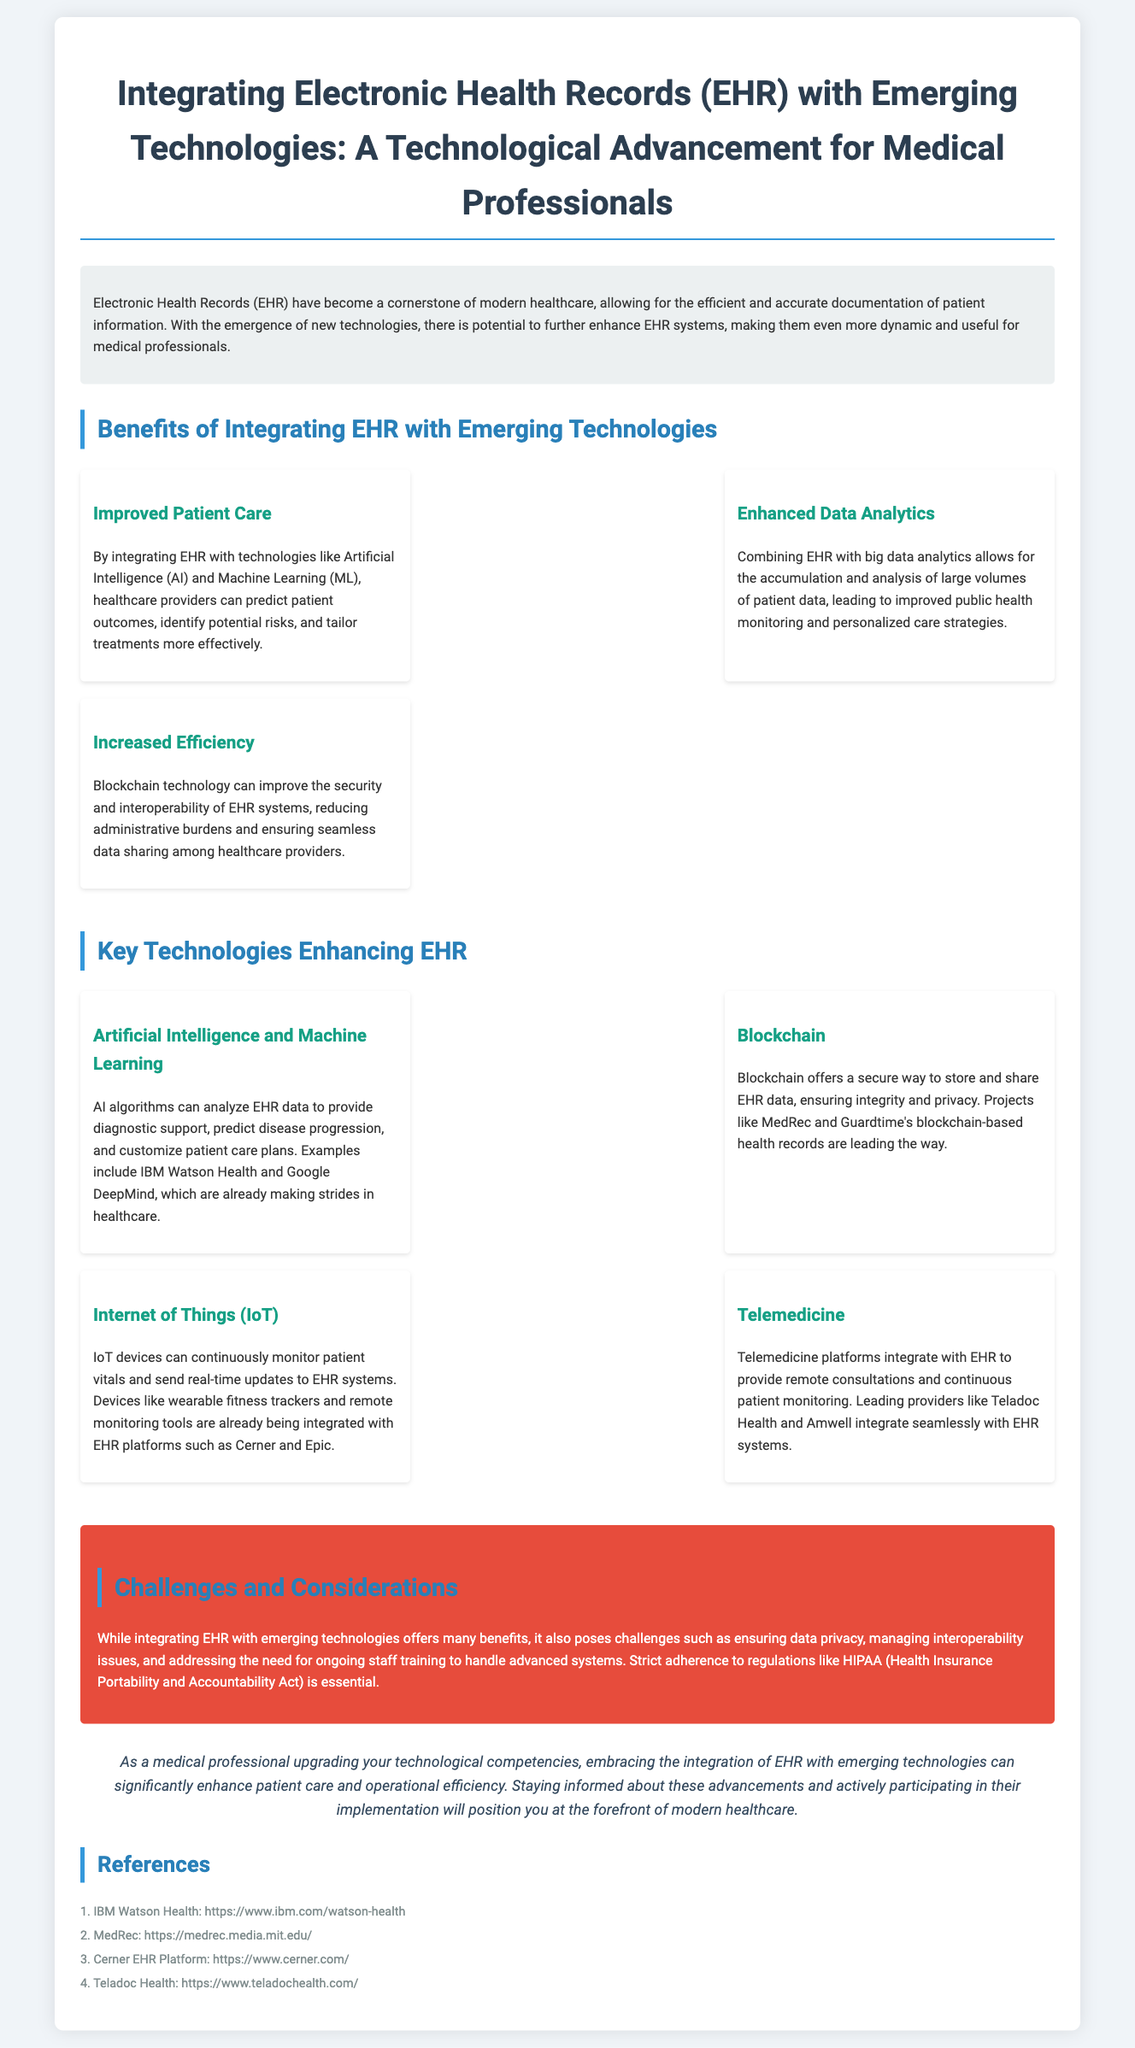What is the main topic of the fact sheet? The main topic of the fact sheet is clearly stated in the title, highlighting the integration of EHR with new technologies.
Answer: Integrating Electronic Health Records (EHR) with Emerging Technologies What technology helps in predicting patient outcomes? The fact sheet mentions specific technologies that enhance patient care, including Artificial Intelligence and Machine Learning.
Answer: Artificial Intelligence and Machine Learning Which blockchain project is mentioned for health records? The document lists specific projects that utilize blockchain for health records, identifying MedRec as one example.
Answer: MedRec What is the potential benefit of combining EHR with big data analytics? The document indicates that combining EHR with big data enables improved public health monitoring and personalized care strategies.
Answer: Improved public health monitoring and personalized care strategies What challenge is emphasized regarding EHR integration? The challenges section points out the need to ensure data privacy as a key concern when integrating EHR with emerging technologies.
Answer: Data privacy Which telemedicine provider is cited in the document? The fact sheet provides specific examples of telemedicine providers integrating with EHR, listing Teladoc Health as one.
Answer: Teladoc Health What is a requirement for healthcare providers mentioned in the challenges section? The challenges section specifies that healthcare providers must adhere to regulations such as HIPAA when integrating EHR and new technologies.
Answer: HIPAA What is shared at the end of the document? The conclusion of the fact sheet highlights the importance of staying informed about technological advancements in healthcare.
Answer: References 